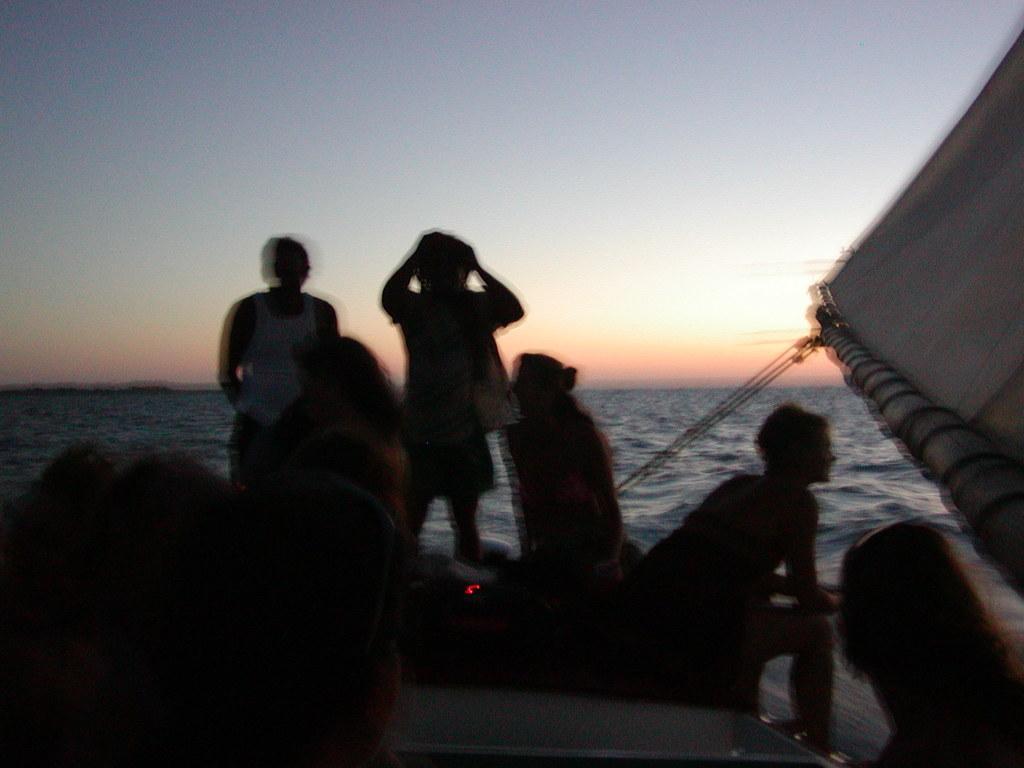In one or two sentences, can you explain what this image depicts? It is a blur image. In this image, we can see a group of people, ropes and sail. Background we can see the water and sky. 